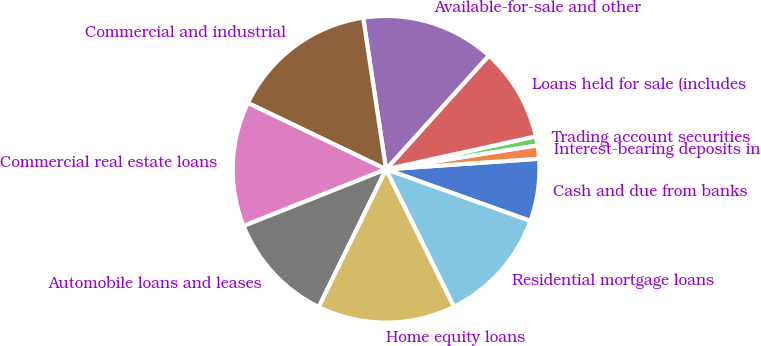Convert chart to OTSL. <chart><loc_0><loc_0><loc_500><loc_500><pie_chart><fcel>Cash and due from banks<fcel>Interest-bearing deposits in<fcel>Trading account securities<fcel>Loans held for sale (includes<fcel>Available-for-sale and other<fcel>Commercial and industrial<fcel>Commercial real estate loans<fcel>Automobile loans and leases<fcel>Home equity loans<fcel>Residential mortgage loans<nl><fcel>6.57%<fcel>1.41%<fcel>0.94%<fcel>9.86%<fcel>14.08%<fcel>15.49%<fcel>13.15%<fcel>11.74%<fcel>14.55%<fcel>12.21%<nl></chart> 